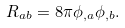<formula> <loc_0><loc_0><loc_500><loc_500>R _ { a b } = 8 \pi \phi _ { , a } \phi _ { , b } .</formula> 